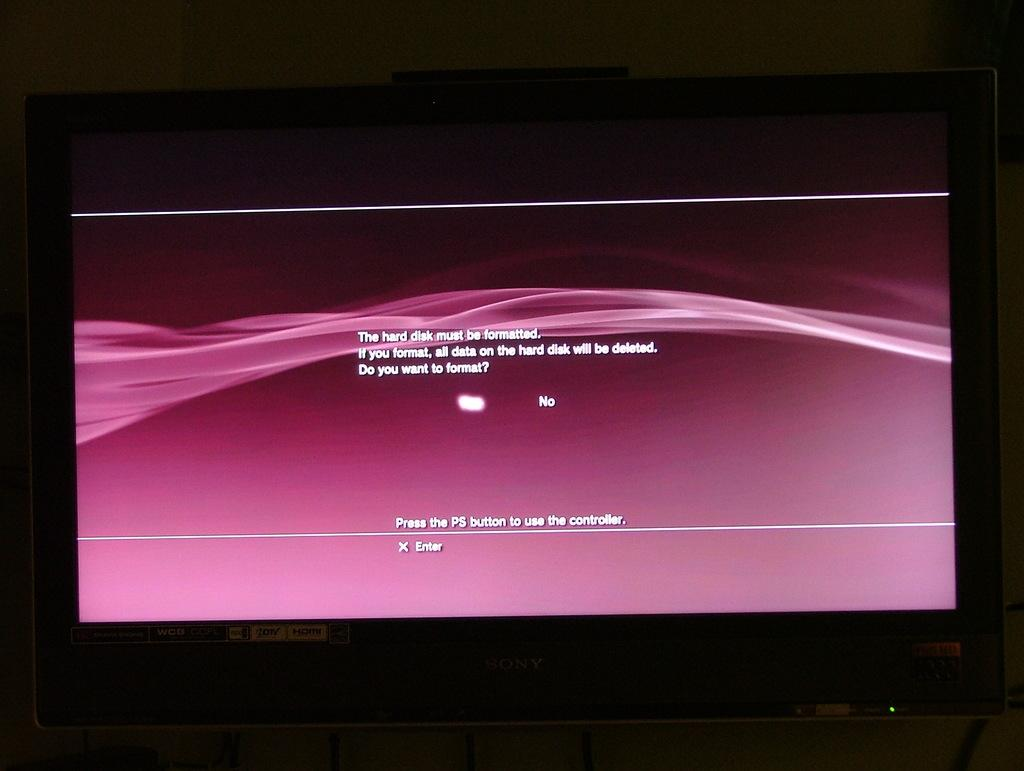Provide a one-sentence caption for the provided image. Playstation loading up on a television asking you to select yes or no. 